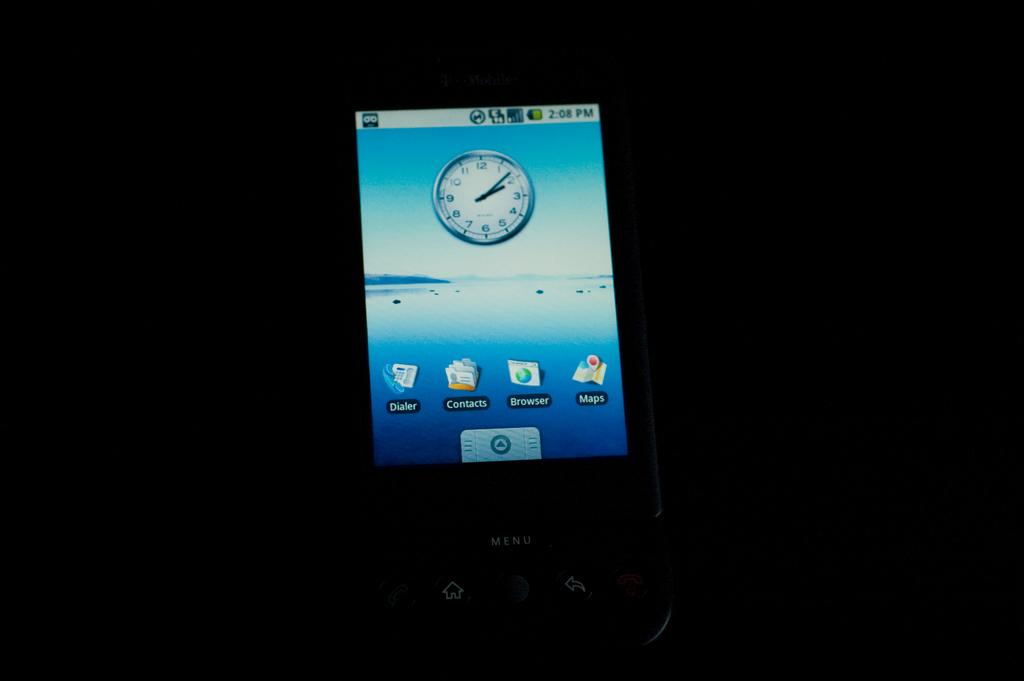<image>
Describe the image concisely. A cell phone has a button that says Menu and is showing the home screen. 